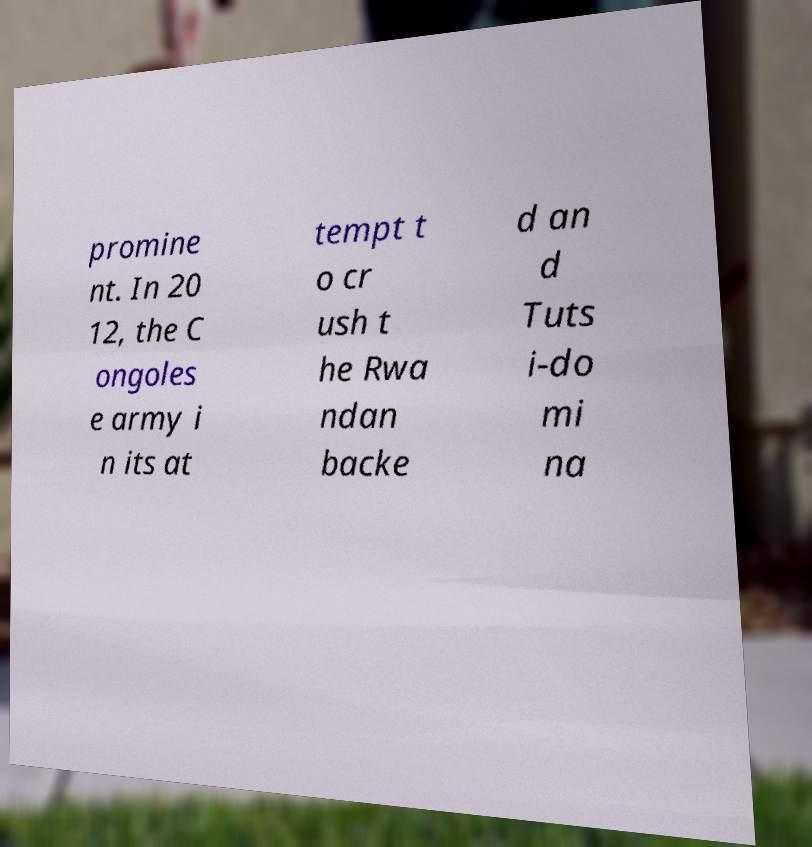Could you extract and type out the text from this image? promine nt. In 20 12, the C ongoles e army i n its at tempt t o cr ush t he Rwa ndan backe d an d Tuts i-do mi na 